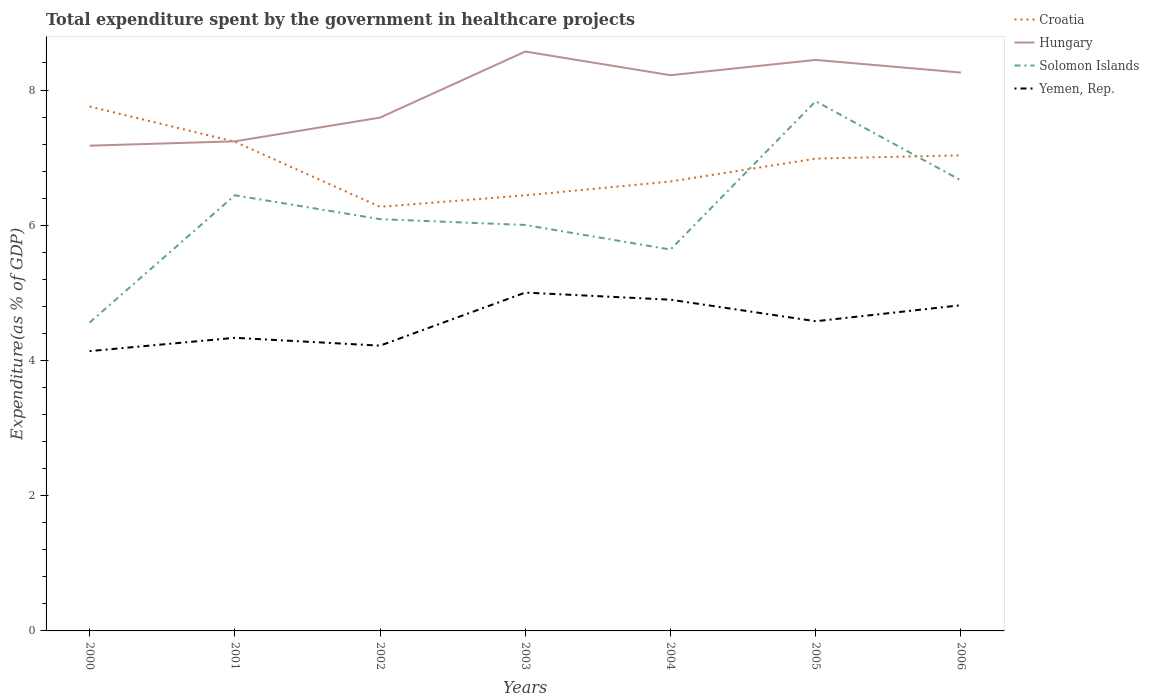Across all years, what is the maximum total expenditure spent by the government in healthcare projects in Hungary?
Your answer should be very brief. 7.18. In which year was the total expenditure spent by the government in healthcare projects in Croatia maximum?
Provide a succinct answer. 2002. What is the total total expenditure spent by the government in healthcare projects in Hungary in the graph?
Offer a terse response. -0.35. What is the difference between the highest and the second highest total expenditure spent by the government in healthcare projects in Solomon Islands?
Offer a very short reply. 3.27. What is the difference between the highest and the lowest total expenditure spent by the government in healthcare projects in Hungary?
Your answer should be very brief. 4. How many lines are there?
Ensure brevity in your answer.  4. What is the difference between two consecutive major ticks on the Y-axis?
Your response must be concise. 2. Are the values on the major ticks of Y-axis written in scientific E-notation?
Provide a short and direct response. No. Does the graph contain grids?
Offer a very short reply. No. How many legend labels are there?
Give a very brief answer. 4. How are the legend labels stacked?
Provide a succinct answer. Vertical. What is the title of the graph?
Ensure brevity in your answer.  Total expenditure spent by the government in healthcare projects. Does "Fiji" appear as one of the legend labels in the graph?
Provide a short and direct response. No. What is the label or title of the Y-axis?
Make the answer very short. Expenditure(as % of GDP). What is the Expenditure(as % of GDP) in Croatia in 2000?
Keep it short and to the point. 7.76. What is the Expenditure(as % of GDP) of Hungary in 2000?
Provide a short and direct response. 7.18. What is the Expenditure(as % of GDP) of Solomon Islands in 2000?
Make the answer very short. 4.56. What is the Expenditure(as % of GDP) of Yemen, Rep. in 2000?
Give a very brief answer. 4.14. What is the Expenditure(as % of GDP) in Croatia in 2001?
Make the answer very short. 7.24. What is the Expenditure(as % of GDP) in Hungary in 2001?
Keep it short and to the point. 7.24. What is the Expenditure(as % of GDP) of Solomon Islands in 2001?
Your answer should be compact. 6.44. What is the Expenditure(as % of GDP) in Yemen, Rep. in 2001?
Make the answer very short. 4.34. What is the Expenditure(as % of GDP) of Croatia in 2002?
Keep it short and to the point. 6.27. What is the Expenditure(as % of GDP) of Hungary in 2002?
Your answer should be compact. 7.59. What is the Expenditure(as % of GDP) in Solomon Islands in 2002?
Provide a succinct answer. 6.09. What is the Expenditure(as % of GDP) of Yemen, Rep. in 2002?
Keep it short and to the point. 4.22. What is the Expenditure(as % of GDP) of Croatia in 2003?
Ensure brevity in your answer.  6.44. What is the Expenditure(as % of GDP) in Hungary in 2003?
Your answer should be compact. 8.57. What is the Expenditure(as % of GDP) of Solomon Islands in 2003?
Offer a terse response. 6. What is the Expenditure(as % of GDP) of Yemen, Rep. in 2003?
Provide a short and direct response. 5. What is the Expenditure(as % of GDP) in Croatia in 2004?
Give a very brief answer. 6.65. What is the Expenditure(as % of GDP) of Hungary in 2004?
Keep it short and to the point. 8.22. What is the Expenditure(as % of GDP) of Solomon Islands in 2004?
Your answer should be compact. 5.64. What is the Expenditure(as % of GDP) in Yemen, Rep. in 2004?
Keep it short and to the point. 4.9. What is the Expenditure(as % of GDP) of Croatia in 2005?
Offer a terse response. 6.99. What is the Expenditure(as % of GDP) of Hungary in 2005?
Your response must be concise. 8.45. What is the Expenditure(as % of GDP) in Solomon Islands in 2005?
Your answer should be very brief. 7.83. What is the Expenditure(as % of GDP) in Yemen, Rep. in 2005?
Your response must be concise. 4.58. What is the Expenditure(as % of GDP) in Croatia in 2006?
Provide a succinct answer. 7.03. What is the Expenditure(as % of GDP) of Hungary in 2006?
Offer a terse response. 8.26. What is the Expenditure(as % of GDP) in Solomon Islands in 2006?
Provide a short and direct response. 6.66. What is the Expenditure(as % of GDP) in Yemen, Rep. in 2006?
Keep it short and to the point. 4.82. Across all years, what is the maximum Expenditure(as % of GDP) in Croatia?
Ensure brevity in your answer.  7.76. Across all years, what is the maximum Expenditure(as % of GDP) of Hungary?
Make the answer very short. 8.57. Across all years, what is the maximum Expenditure(as % of GDP) of Solomon Islands?
Your answer should be compact. 7.83. Across all years, what is the maximum Expenditure(as % of GDP) of Yemen, Rep.?
Provide a short and direct response. 5. Across all years, what is the minimum Expenditure(as % of GDP) of Croatia?
Your answer should be very brief. 6.27. Across all years, what is the minimum Expenditure(as % of GDP) of Hungary?
Provide a short and direct response. 7.18. Across all years, what is the minimum Expenditure(as % of GDP) in Solomon Islands?
Offer a terse response. 4.56. Across all years, what is the minimum Expenditure(as % of GDP) of Yemen, Rep.?
Offer a very short reply. 4.14. What is the total Expenditure(as % of GDP) in Croatia in the graph?
Offer a very short reply. 48.37. What is the total Expenditure(as % of GDP) in Hungary in the graph?
Your answer should be very brief. 55.5. What is the total Expenditure(as % of GDP) of Solomon Islands in the graph?
Provide a short and direct response. 43.24. What is the total Expenditure(as % of GDP) in Yemen, Rep. in the graph?
Provide a succinct answer. 31.99. What is the difference between the Expenditure(as % of GDP) of Croatia in 2000 and that in 2001?
Your answer should be compact. 0.52. What is the difference between the Expenditure(as % of GDP) in Hungary in 2000 and that in 2001?
Provide a short and direct response. -0.06. What is the difference between the Expenditure(as % of GDP) in Solomon Islands in 2000 and that in 2001?
Keep it short and to the point. -1.88. What is the difference between the Expenditure(as % of GDP) in Yemen, Rep. in 2000 and that in 2001?
Give a very brief answer. -0.2. What is the difference between the Expenditure(as % of GDP) of Croatia in 2000 and that in 2002?
Offer a very short reply. 1.48. What is the difference between the Expenditure(as % of GDP) of Hungary in 2000 and that in 2002?
Offer a very short reply. -0.42. What is the difference between the Expenditure(as % of GDP) of Solomon Islands in 2000 and that in 2002?
Provide a short and direct response. -1.53. What is the difference between the Expenditure(as % of GDP) of Yemen, Rep. in 2000 and that in 2002?
Your answer should be compact. -0.08. What is the difference between the Expenditure(as % of GDP) of Croatia in 2000 and that in 2003?
Provide a short and direct response. 1.31. What is the difference between the Expenditure(as % of GDP) of Hungary in 2000 and that in 2003?
Offer a terse response. -1.39. What is the difference between the Expenditure(as % of GDP) in Solomon Islands in 2000 and that in 2003?
Give a very brief answer. -1.44. What is the difference between the Expenditure(as % of GDP) of Yemen, Rep. in 2000 and that in 2003?
Offer a terse response. -0.87. What is the difference between the Expenditure(as % of GDP) of Croatia in 2000 and that in 2004?
Give a very brief answer. 1.11. What is the difference between the Expenditure(as % of GDP) in Hungary in 2000 and that in 2004?
Offer a terse response. -1.04. What is the difference between the Expenditure(as % of GDP) of Solomon Islands in 2000 and that in 2004?
Your answer should be very brief. -1.08. What is the difference between the Expenditure(as % of GDP) of Yemen, Rep. in 2000 and that in 2004?
Your response must be concise. -0.76. What is the difference between the Expenditure(as % of GDP) in Croatia in 2000 and that in 2005?
Make the answer very short. 0.77. What is the difference between the Expenditure(as % of GDP) of Hungary in 2000 and that in 2005?
Your response must be concise. -1.27. What is the difference between the Expenditure(as % of GDP) of Solomon Islands in 2000 and that in 2005?
Provide a succinct answer. -3.27. What is the difference between the Expenditure(as % of GDP) in Yemen, Rep. in 2000 and that in 2005?
Your response must be concise. -0.44. What is the difference between the Expenditure(as % of GDP) of Croatia in 2000 and that in 2006?
Keep it short and to the point. 0.72. What is the difference between the Expenditure(as % of GDP) in Hungary in 2000 and that in 2006?
Your answer should be very brief. -1.08. What is the difference between the Expenditure(as % of GDP) of Solomon Islands in 2000 and that in 2006?
Ensure brevity in your answer.  -2.1. What is the difference between the Expenditure(as % of GDP) in Yemen, Rep. in 2000 and that in 2006?
Your answer should be compact. -0.68. What is the difference between the Expenditure(as % of GDP) in Croatia in 2001 and that in 2002?
Your response must be concise. 0.96. What is the difference between the Expenditure(as % of GDP) of Hungary in 2001 and that in 2002?
Your answer should be compact. -0.35. What is the difference between the Expenditure(as % of GDP) of Solomon Islands in 2001 and that in 2002?
Ensure brevity in your answer.  0.35. What is the difference between the Expenditure(as % of GDP) in Yemen, Rep. in 2001 and that in 2002?
Ensure brevity in your answer.  0.12. What is the difference between the Expenditure(as % of GDP) of Croatia in 2001 and that in 2003?
Ensure brevity in your answer.  0.79. What is the difference between the Expenditure(as % of GDP) in Hungary in 2001 and that in 2003?
Keep it short and to the point. -1.33. What is the difference between the Expenditure(as % of GDP) in Solomon Islands in 2001 and that in 2003?
Make the answer very short. 0.44. What is the difference between the Expenditure(as % of GDP) of Yemen, Rep. in 2001 and that in 2003?
Offer a very short reply. -0.67. What is the difference between the Expenditure(as % of GDP) in Croatia in 2001 and that in 2004?
Ensure brevity in your answer.  0.59. What is the difference between the Expenditure(as % of GDP) of Hungary in 2001 and that in 2004?
Offer a very short reply. -0.98. What is the difference between the Expenditure(as % of GDP) in Solomon Islands in 2001 and that in 2004?
Your answer should be compact. 0.8. What is the difference between the Expenditure(as % of GDP) in Yemen, Rep. in 2001 and that in 2004?
Your response must be concise. -0.56. What is the difference between the Expenditure(as % of GDP) of Croatia in 2001 and that in 2005?
Make the answer very short. 0.25. What is the difference between the Expenditure(as % of GDP) of Hungary in 2001 and that in 2005?
Offer a terse response. -1.2. What is the difference between the Expenditure(as % of GDP) in Solomon Islands in 2001 and that in 2005?
Offer a very short reply. -1.39. What is the difference between the Expenditure(as % of GDP) of Yemen, Rep. in 2001 and that in 2005?
Offer a terse response. -0.25. What is the difference between the Expenditure(as % of GDP) of Croatia in 2001 and that in 2006?
Ensure brevity in your answer.  0.2. What is the difference between the Expenditure(as % of GDP) of Hungary in 2001 and that in 2006?
Your answer should be compact. -1.02. What is the difference between the Expenditure(as % of GDP) of Solomon Islands in 2001 and that in 2006?
Provide a short and direct response. -0.22. What is the difference between the Expenditure(as % of GDP) in Yemen, Rep. in 2001 and that in 2006?
Offer a very short reply. -0.48. What is the difference between the Expenditure(as % of GDP) in Croatia in 2002 and that in 2003?
Provide a short and direct response. -0.17. What is the difference between the Expenditure(as % of GDP) of Hungary in 2002 and that in 2003?
Your answer should be very brief. -0.98. What is the difference between the Expenditure(as % of GDP) in Solomon Islands in 2002 and that in 2003?
Your response must be concise. 0.09. What is the difference between the Expenditure(as % of GDP) in Yemen, Rep. in 2002 and that in 2003?
Keep it short and to the point. -0.78. What is the difference between the Expenditure(as % of GDP) of Croatia in 2002 and that in 2004?
Provide a succinct answer. -0.37. What is the difference between the Expenditure(as % of GDP) in Hungary in 2002 and that in 2004?
Make the answer very short. -0.63. What is the difference between the Expenditure(as % of GDP) of Solomon Islands in 2002 and that in 2004?
Give a very brief answer. 0.45. What is the difference between the Expenditure(as % of GDP) in Yemen, Rep. in 2002 and that in 2004?
Keep it short and to the point. -0.68. What is the difference between the Expenditure(as % of GDP) of Croatia in 2002 and that in 2005?
Your answer should be very brief. -0.71. What is the difference between the Expenditure(as % of GDP) of Hungary in 2002 and that in 2005?
Ensure brevity in your answer.  -0.85. What is the difference between the Expenditure(as % of GDP) in Solomon Islands in 2002 and that in 2005?
Make the answer very short. -1.74. What is the difference between the Expenditure(as % of GDP) in Yemen, Rep. in 2002 and that in 2005?
Your answer should be compact. -0.36. What is the difference between the Expenditure(as % of GDP) in Croatia in 2002 and that in 2006?
Make the answer very short. -0.76. What is the difference between the Expenditure(as % of GDP) in Hungary in 2002 and that in 2006?
Your response must be concise. -0.67. What is the difference between the Expenditure(as % of GDP) in Solomon Islands in 2002 and that in 2006?
Provide a succinct answer. -0.57. What is the difference between the Expenditure(as % of GDP) of Yemen, Rep. in 2002 and that in 2006?
Ensure brevity in your answer.  -0.6. What is the difference between the Expenditure(as % of GDP) in Croatia in 2003 and that in 2004?
Give a very brief answer. -0.2. What is the difference between the Expenditure(as % of GDP) in Hungary in 2003 and that in 2004?
Your answer should be very brief. 0.35. What is the difference between the Expenditure(as % of GDP) of Solomon Islands in 2003 and that in 2004?
Provide a short and direct response. 0.36. What is the difference between the Expenditure(as % of GDP) of Yemen, Rep. in 2003 and that in 2004?
Give a very brief answer. 0.11. What is the difference between the Expenditure(as % of GDP) in Croatia in 2003 and that in 2005?
Make the answer very short. -0.54. What is the difference between the Expenditure(as % of GDP) of Hungary in 2003 and that in 2005?
Keep it short and to the point. 0.12. What is the difference between the Expenditure(as % of GDP) in Solomon Islands in 2003 and that in 2005?
Offer a terse response. -1.83. What is the difference between the Expenditure(as % of GDP) of Yemen, Rep. in 2003 and that in 2005?
Your answer should be compact. 0.42. What is the difference between the Expenditure(as % of GDP) in Croatia in 2003 and that in 2006?
Offer a very short reply. -0.59. What is the difference between the Expenditure(as % of GDP) of Hungary in 2003 and that in 2006?
Provide a short and direct response. 0.31. What is the difference between the Expenditure(as % of GDP) of Solomon Islands in 2003 and that in 2006?
Provide a succinct answer. -0.66. What is the difference between the Expenditure(as % of GDP) in Yemen, Rep. in 2003 and that in 2006?
Your response must be concise. 0.19. What is the difference between the Expenditure(as % of GDP) of Croatia in 2004 and that in 2005?
Make the answer very short. -0.34. What is the difference between the Expenditure(as % of GDP) of Hungary in 2004 and that in 2005?
Offer a very short reply. -0.23. What is the difference between the Expenditure(as % of GDP) in Solomon Islands in 2004 and that in 2005?
Your answer should be compact. -2.19. What is the difference between the Expenditure(as % of GDP) in Yemen, Rep. in 2004 and that in 2005?
Your answer should be very brief. 0.32. What is the difference between the Expenditure(as % of GDP) in Croatia in 2004 and that in 2006?
Offer a very short reply. -0.39. What is the difference between the Expenditure(as % of GDP) in Hungary in 2004 and that in 2006?
Your answer should be compact. -0.04. What is the difference between the Expenditure(as % of GDP) of Solomon Islands in 2004 and that in 2006?
Make the answer very short. -1.02. What is the difference between the Expenditure(as % of GDP) in Yemen, Rep. in 2004 and that in 2006?
Provide a succinct answer. 0.08. What is the difference between the Expenditure(as % of GDP) in Croatia in 2005 and that in 2006?
Your response must be concise. -0.05. What is the difference between the Expenditure(as % of GDP) in Hungary in 2005 and that in 2006?
Keep it short and to the point. 0.19. What is the difference between the Expenditure(as % of GDP) of Solomon Islands in 2005 and that in 2006?
Keep it short and to the point. 1.17. What is the difference between the Expenditure(as % of GDP) in Yemen, Rep. in 2005 and that in 2006?
Offer a terse response. -0.24. What is the difference between the Expenditure(as % of GDP) of Croatia in 2000 and the Expenditure(as % of GDP) of Hungary in 2001?
Provide a short and direct response. 0.51. What is the difference between the Expenditure(as % of GDP) of Croatia in 2000 and the Expenditure(as % of GDP) of Solomon Islands in 2001?
Provide a short and direct response. 1.31. What is the difference between the Expenditure(as % of GDP) in Croatia in 2000 and the Expenditure(as % of GDP) in Yemen, Rep. in 2001?
Offer a very short reply. 3.42. What is the difference between the Expenditure(as % of GDP) in Hungary in 2000 and the Expenditure(as % of GDP) in Solomon Islands in 2001?
Offer a terse response. 0.73. What is the difference between the Expenditure(as % of GDP) in Hungary in 2000 and the Expenditure(as % of GDP) in Yemen, Rep. in 2001?
Keep it short and to the point. 2.84. What is the difference between the Expenditure(as % of GDP) of Solomon Islands in 2000 and the Expenditure(as % of GDP) of Yemen, Rep. in 2001?
Keep it short and to the point. 0.23. What is the difference between the Expenditure(as % of GDP) in Croatia in 2000 and the Expenditure(as % of GDP) in Hungary in 2002?
Give a very brief answer. 0.16. What is the difference between the Expenditure(as % of GDP) of Croatia in 2000 and the Expenditure(as % of GDP) of Solomon Islands in 2002?
Offer a very short reply. 1.67. What is the difference between the Expenditure(as % of GDP) of Croatia in 2000 and the Expenditure(as % of GDP) of Yemen, Rep. in 2002?
Make the answer very short. 3.54. What is the difference between the Expenditure(as % of GDP) of Hungary in 2000 and the Expenditure(as % of GDP) of Solomon Islands in 2002?
Keep it short and to the point. 1.09. What is the difference between the Expenditure(as % of GDP) in Hungary in 2000 and the Expenditure(as % of GDP) in Yemen, Rep. in 2002?
Give a very brief answer. 2.96. What is the difference between the Expenditure(as % of GDP) in Solomon Islands in 2000 and the Expenditure(as % of GDP) in Yemen, Rep. in 2002?
Offer a very short reply. 0.34. What is the difference between the Expenditure(as % of GDP) in Croatia in 2000 and the Expenditure(as % of GDP) in Hungary in 2003?
Your answer should be compact. -0.81. What is the difference between the Expenditure(as % of GDP) in Croatia in 2000 and the Expenditure(as % of GDP) in Solomon Islands in 2003?
Give a very brief answer. 1.75. What is the difference between the Expenditure(as % of GDP) of Croatia in 2000 and the Expenditure(as % of GDP) of Yemen, Rep. in 2003?
Your answer should be compact. 2.75. What is the difference between the Expenditure(as % of GDP) in Hungary in 2000 and the Expenditure(as % of GDP) in Solomon Islands in 2003?
Provide a succinct answer. 1.17. What is the difference between the Expenditure(as % of GDP) in Hungary in 2000 and the Expenditure(as % of GDP) in Yemen, Rep. in 2003?
Offer a very short reply. 2.17. What is the difference between the Expenditure(as % of GDP) of Solomon Islands in 2000 and the Expenditure(as % of GDP) of Yemen, Rep. in 2003?
Your response must be concise. -0.44. What is the difference between the Expenditure(as % of GDP) in Croatia in 2000 and the Expenditure(as % of GDP) in Hungary in 2004?
Your answer should be compact. -0.46. What is the difference between the Expenditure(as % of GDP) of Croatia in 2000 and the Expenditure(as % of GDP) of Solomon Islands in 2004?
Your answer should be very brief. 2.12. What is the difference between the Expenditure(as % of GDP) of Croatia in 2000 and the Expenditure(as % of GDP) of Yemen, Rep. in 2004?
Your response must be concise. 2.86. What is the difference between the Expenditure(as % of GDP) in Hungary in 2000 and the Expenditure(as % of GDP) in Solomon Islands in 2004?
Give a very brief answer. 1.54. What is the difference between the Expenditure(as % of GDP) of Hungary in 2000 and the Expenditure(as % of GDP) of Yemen, Rep. in 2004?
Provide a succinct answer. 2.28. What is the difference between the Expenditure(as % of GDP) of Solomon Islands in 2000 and the Expenditure(as % of GDP) of Yemen, Rep. in 2004?
Ensure brevity in your answer.  -0.34. What is the difference between the Expenditure(as % of GDP) of Croatia in 2000 and the Expenditure(as % of GDP) of Hungary in 2005?
Offer a terse response. -0.69. What is the difference between the Expenditure(as % of GDP) of Croatia in 2000 and the Expenditure(as % of GDP) of Solomon Islands in 2005?
Provide a succinct answer. -0.08. What is the difference between the Expenditure(as % of GDP) of Croatia in 2000 and the Expenditure(as % of GDP) of Yemen, Rep. in 2005?
Make the answer very short. 3.18. What is the difference between the Expenditure(as % of GDP) of Hungary in 2000 and the Expenditure(as % of GDP) of Solomon Islands in 2005?
Your answer should be compact. -0.66. What is the difference between the Expenditure(as % of GDP) in Hungary in 2000 and the Expenditure(as % of GDP) in Yemen, Rep. in 2005?
Ensure brevity in your answer.  2.6. What is the difference between the Expenditure(as % of GDP) in Solomon Islands in 2000 and the Expenditure(as % of GDP) in Yemen, Rep. in 2005?
Provide a short and direct response. -0.02. What is the difference between the Expenditure(as % of GDP) in Croatia in 2000 and the Expenditure(as % of GDP) in Hungary in 2006?
Provide a succinct answer. -0.5. What is the difference between the Expenditure(as % of GDP) in Croatia in 2000 and the Expenditure(as % of GDP) in Solomon Islands in 2006?
Your answer should be compact. 1.09. What is the difference between the Expenditure(as % of GDP) in Croatia in 2000 and the Expenditure(as % of GDP) in Yemen, Rep. in 2006?
Offer a terse response. 2.94. What is the difference between the Expenditure(as % of GDP) in Hungary in 2000 and the Expenditure(as % of GDP) in Solomon Islands in 2006?
Provide a short and direct response. 0.51. What is the difference between the Expenditure(as % of GDP) in Hungary in 2000 and the Expenditure(as % of GDP) in Yemen, Rep. in 2006?
Make the answer very short. 2.36. What is the difference between the Expenditure(as % of GDP) of Solomon Islands in 2000 and the Expenditure(as % of GDP) of Yemen, Rep. in 2006?
Offer a very short reply. -0.26. What is the difference between the Expenditure(as % of GDP) of Croatia in 2001 and the Expenditure(as % of GDP) of Hungary in 2002?
Your answer should be very brief. -0.36. What is the difference between the Expenditure(as % of GDP) in Croatia in 2001 and the Expenditure(as % of GDP) in Solomon Islands in 2002?
Offer a very short reply. 1.15. What is the difference between the Expenditure(as % of GDP) of Croatia in 2001 and the Expenditure(as % of GDP) of Yemen, Rep. in 2002?
Your response must be concise. 3.02. What is the difference between the Expenditure(as % of GDP) in Hungary in 2001 and the Expenditure(as % of GDP) in Solomon Islands in 2002?
Make the answer very short. 1.15. What is the difference between the Expenditure(as % of GDP) of Hungary in 2001 and the Expenditure(as % of GDP) of Yemen, Rep. in 2002?
Offer a terse response. 3.02. What is the difference between the Expenditure(as % of GDP) in Solomon Islands in 2001 and the Expenditure(as % of GDP) in Yemen, Rep. in 2002?
Give a very brief answer. 2.22. What is the difference between the Expenditure(as % of GDP) in Croatia in 2001 and the Expenditure(as % of GDP) in Hungary in 2003?
Offer a very short reply. -1.33. What is the difference between the Expenditure(as % of GDP) of Croatia in 2001 and the Expenditure(as % of GDP) of Solomon Islands in 2003?
Your answer should be very brief. 1.23. What is the difference between the Expenditure(as % of GDP) in Croatia in 2001 and the Expenditure(as % of GDP) in Yemen, Rep. in 2003?
Keep it short and to the point. 2.23. What is the difference between the Expenditure(as % of GDP) in Hungary in 2001 and the Expenditure(as % of GDP) in Solomon Islands in 2003?
Make the answer very short. 1.24. What is the difference between the Expenditure(as % of GDP) of Hungary in 2001 and the Expenditure(as % of GDP) of Yemen, Rep. in 2003?
Provide a succinct answer. 2.24. What is the difference between the Expenditure(as % of GDP) of Solomon Islands in 2001 and the Expenditure(as % of GDP) of Yemen, Rep. in 2003?
Your answer should be compact. 1.44. What is the difference between the Expenditure(as % of GDP) of Croatia in 2001 and the Expenditure(as % of GDP) of Hungary in 2004?
Offer a very short reply. -0.98. What is the difference between the Expenditure(as % of GDP) of Croatia in 2001 and the Expenditure(as % of GDP) of Solomon Islands in 2004?
Provide a succinct answer. 1.6. What is the difference between the Expenditure(as % of GDP) of Croatia in 2001 and the Expenditure(as % of GDP) of Yemen, Rep. in 2004?
Offer a terse response. 2.34. What is the difference between the Expenditure(as % of GDP) in Hungary in 2001 and the Expenditure(as % of GDP) in Solomon Islands in 2004?
Your answer should be compact. 1.6. What is the difference between the Expenditure(as % of GDP) in Hungary in 2001 and the Expenditure(as % of GDP) in Yemen, Rep. in 2004?
Give a very brief answer. 2.34. What is the difference between the Expenditure(as % of GDP) in Solomon Islands in 2001 and the Expenditure(as % of GDP) in Yemen, Rep. in 2004?
Provide a short and direct response. 1.54. What is the difference between the Expenditure(as % of GDP) of Croatia in 2001 and the Expenditure(as % of GDP) of Hungary in 2005?
Provide a succinct answer. -1.21. What is the difference between the Expenditure(as % of GDP) in Croatia in 2001 and the Expenditure(as % of GDP) in Solomon Islands in 2005?
Give a very brief answer. -0.6. What is the difference between the Expenditure(as % of GDP) of Croatia in 2001 and the Expenditure(as % of GDP) of Yemen, Rep. in 2005?
Ensure brevity in your answer.  2.66. What is the difference between the Expenditure(as % of GDP) in Hungary in 2001 and the Expenditure(as % of GDP) in Solomon Islands in 2005?
Give a very brief answer. -0.59. What is the difference between the Expenditure(as % of GDP) in Hungary in 2001 and the Expenditure(as % of GDP) in Yemen, Rep. in 2005?
Make the answer very short. 2.66. What is the difference between the Expenditure(as % of GDP) in Solomon Islands in 2001 and the Expenditure(as % of GDP) in Yemen, Rep. in 2005?
Give a very brief answer. 1.86. What is the difference between the Expenditure(as % of GDP) of Croatia in 2001 and the Expenditure(as % of GDP) of Hungary in 2006?
Keep it short and to the point. -1.02. What is the difference between the Expenditure(as % of GDP) in Croatia in 2001 and the Expenditure(as % of GDP) in Solomon Islands in 2006?
Keep it short and to the point. 0.57. What is the difference between the Expenditure(as % of GDP) in Croatia in 2001 and the Expenditure(as % of GDP) in Yemen, Rep. in 2006?
Offer a terse response. 2.42. What is the difference between the Expenditure(as % of GDP) of Hungary in 2001 and the Expenditure(as % of GDP) of Solomon Islands in 2006?
Your response must be concise. 0.58. What is the difference between the Expenditure(as % of GDP) in Hungary in 2001 and the Expenditure(as % of GDP) in Yemen, Rep. in 2006?
Give a very brief answer. 2.42. What is the difference between the Expenditure(as % of GDP) of Solomon Islands in 2001 and the Expenditure(as % of GDP) of Yemen, Rep. in 2006?
Your answer should be compact. 1.63. What is the difference between the Expenditure(as % of GDP) in Croatia in 2002 and the Expenditure(as % of GDP) in Hungary in 2003?
Give a very brief answer. -2.3. What is the difference between the Expenditure(as % of GDP) of Croatia in 2002 and the Expenditure(as % of GDP) of Solomon Islands in 2003?
Make the answer very short. 0.27. What is the difference between the Expenditure(as % of GDP) in Croatia in 2002 and the Expenditure(as % of GDP) in Yemen, Rep. in 2003?
Ensure brevity in your answer.  1.27. What is the difference between the Expenditure(as % of GDP) of Hungary in 2002 and the Expenditure(as % of GDP) of Solomon Islands in 2003?
Provide a succinct answer. 1.59. What is the difference between the Expenditure(as % of GDP) of Hungary in 2002 and the Expenditure(as % of GDP) of Yemen, Rep. in 2003?
Make the answer very short. 2.59. What is the difference between the Expenditure(as % of GDP) in Solomon Islands in 2002 and the Expenditure(as % of GDP) in Yemen, Rep. in 2003?
Offer a terse response. 1.09. What is the difference between the Expenditure(as % of GDP) of Croatia in 2002 and the Expenditure(as % of GDP) of Hungary in 2004?
Give a very brief answer. -1.95. What is the difference between the Expenditure(as % of GDP) in Croatia in 2002 and the Expenditure(as % of GDP) in Solomon Islands in 2004?
Ensure brevity in your answer.  0.63. What is the difference between the Expenditure(as % of GDP) of Croatia in 2002 and the Expenditure(as % of GDP) of Yemen, Rep. in 2004?
Make the answer very short. 1.37. What is the difference between the Expenditure(as % of GDP) of Hungary in 2002 and the Expenditure(as % of GDP) of Solomon Islands in 2004?
Provide a succinct answer. 1.95. What is the difference between the Expenditure(as % of GDP) of Hungary in 2002 and the Expenditure(as % of GDP) of Yemen, Rep. in 2004?
Your response must be concise. 2.69. What is the difference between the Expenditure(as % of GDP) of Solomon Islands in 2002 and the Expenditure(as % of GDP) of Yemen, Rep. in 2004?
Make the answer very short. 1.19. What is the difference between the Expenditure(as % of GDP) of Croatia in 2002 and the Expenditure(as % of GDP) of Hungary in 2005?
Make the answer very short. -2.17. What is the difference between the Expenditure(as % of GDP) of Croatia in 2002 and the Expenditure(as % of GDP) of Solomon Islands in 2005?
Give a very brief answer. -1.56. What is the difference between the Expenditure(as % of GDP) of Croatia in 2002 and the Expenditure(as % of GDP) of Yemen, Rep. in 2005?
Give a very brief answer. 1.69. What is the difference between the Expenditure(as % of GDP) in Hungary in 2002 and the Expenditure(as % of GDP) in Solomon Islands in 2005?
Your response must be concise. -0.24. What is the difference between the Expenditure(as % of GDP) of Hungary in 2002 and the Expenditure(as % of GDP) of Yemen, Rep. in 2005?
Your answer should be compact. 3.01. What is the difference between the Expenditure(as % of GDP) in Solomon Islands in 2002 and the Expenditure(as % of GDP) in Yemen, Rep. in 2005?
Your response must be concise. 1.51. What is the difference between the Expenditure(as % of GDP) of Croatia in 2002 and the Expenditure(as % of GDP) of Hungary in 2006?
Your answer should be compact. -1.99. What is the difference between the Expenditure(as % of GDP) of Croatia in 2002 and the Expenditure(as % of GDP) of Solomon Islands in 2006?
Offer a terse response. -0.39. What is the difference between the Expenditure(as % of GDP) of Croatia in 2002 and the Expenditure(as % of GDP) of Yemen, Rep. in 2006?
Offer a terse response. 1.46. What is the difference between the Expenditure(as % of GDP) in Hungary in 2002 and the Expenditure(as % of GDP) in Solomon Islands in 2006?
Your response must be concise. 0.93. What is the difference between the Expenditure(as % of GDP) in Hungary in 2002 and the Expenditure(as % of GDP) in Yemen, Rep. in 2006?
Keep it short and to the point. 2.78. What is the difference between the Expenditure(as % of GDP) in Solomon Islands in 2002 and the Expenditure(as % of GDP) in Yemen, Rep. in 2006?
Your answer should be compact. 1.27. What is the difference between the Expenditure(as % of GDP) of Croatia in 2003 and the Expenditure(as % of GDP) of Hungary in 2004?
Offer a very short reply. -1.78. What is the difference between the Expenditure(as % of GDP) of Croatia in 2003 and the Expenditure(as % of GDP) of Solomon Islands in 2004?
Your response must be concise. 0.8. What is the difference between the Expenditure(as % of GDP) of Croatia in 2003 and the Expenditure(as % of GDP) of Yemen, Rep. in 2004?
Provide a short and direct response. 1.54. What is the difference between the Expenditure(as % of GDP) in Hungary in 2003 and the Expenditure(as % of GDP) in Solomon Islands in 2004?
Ensure brevity in your answer.  2.93. What is the difference between the Expenditure(as % of GDP) in Hungary in 2003 and the Expenditure(as % of GDP) in Yemen, Rep. in 2004?
Ensure brevity in your answer.  3.67. What is the difference between the Expenditure(as % of GDP) of Solomon Islands in 2003 and the Expenditure(as % of GDP) of Yemen, Rep. in 2004?
Your answer should be compact. 1.11. What is the difference between the Expenditure(as % of GDP) in Croatia in 2003 and the Expenditure(as % of GDP) in Hungary in 2005?
Provide a succinct answer. -2. What is the difference between the Expenditure(as % of GDP) in Croatia in 2003 and the Expenditure(as % of GDP) in Solomon Islands in 2005?
Your answer should be compact. -1.39. What is the difference between the Expenditure(as % of GDP) of Croatia in 2003 and the Expenditure(as % of GDP) of Yemen, Rep. in 2005?
Offer a very short reply. 1.86. What is the difference between the Expenditure(as % of GDP) of Hungary in 2003 and the Expenditure(as % of GDP) of Solomon Islands in 2005?
Keep it short and to the point. 0.73. What is the difference between the Expenditure(as % of GDP) of Hungary in 2003 and the Expenditure(as % of GDP) of Yemen, Rep. in 2005?
Your answer should be compact. 3.99. What is the difference between the Expenditure(as % of GDP) in Solomon Islands in 2003 and the Expenditure(as % of GDP) in Yemen, Rep. in 2005?
Ensure brevity in your answer.  1.42. What is the difference between the Expenditure(as % of GDP) of Croatia in 2003 and the Expenditure(as % of GDP) of Hungary in 2006?
Provide a short and direct response. -1.82. What is the difference between the Expenditure(as % of GDP) of Croatia in 2003 and the Expenditure(as % of GDP) of Solomon Islands in 2006?
Offer a terse response. -0.22. What is the difference between the Expenditure(as % of GDP) in Croatia in 2003 and the Expenditure(as % of GDP) in Yemen, Rep. in 2006?
Ensure brevity in your answer.  1.63. What is the difference between the Expenditure(as % of GDP) in Hungary in 2003 and the Expenditure(as % of GDP) in Solomon Islands in 2006?
Offer a very short reply. 1.91. What is the difference between the Expenditure(as % of GDP) in Hungary in 2003 and the Expenditure(as % of GDP) in Yemen, Rep. in 2006?
Provide a short and direct response. 3.75. What is the difference between the Expenditure(as % of GDP) of Solomon Islands in 2003 and the Expenditure(as % of GDP) of Yemen, Rep. in 2006?
Make the answer very short. 1.19. What is the difference between the Expenditure(as % of GDP) in Croatia in 2004 and the Expenditure(as % of GDP) in Hungary in 2005?
Ensure brevity in your answer.  -1.8. What is the difference between the Expenditure(as % of GDP) in Croatia in 2004 and the Expenditure(as % of GDP) in Solomon Islands in 2005?
Offer a terse response. -1.19. What is the difference between the Expenditure(as % of GDP) in Croatia in 2004 and the Expenditure(as % of GDP) in Yemen, Rep. in 2005?
Offer a terse response. 2.07. What is the difference between the Expenditure(as % of GDP) in Hungary in 2004 and the Expenditure(as % of GDP) in Solomon Islands in 2005?
Keep it short and to the point. 0.38. What is the difference between the Expenditure(as % of GDP) of Hungary in 2004 and the Expenditure(as % of GDP) of Yemen, Rep. in 2005?
Offer a very short reply. 3.64. What is the difference between the Expenditure(as % of GDP) of Solomon Islands in 2004 and the Expenditure(as % of GDP) of Yemen, Rep. in 2005?
Give a very brief answer. 1.06. What is the difference between the Expenditure(as % of GDP) of Croatia in 2004 and the Expenditure(as % of GDP) of Hungary in 2006?
Make the answer very short. -1.61. What is the difference between the Expenditure(as % of GDP) of Croatia in 2004 and the Expenditure(as % of GDP) of Solomon Islands in 2006?
Provide a short and direct response. -0.02. What is the difference between the Expenditure(as % of GDP) of Croatia in 2004 and the Expenditure(as % of GDP) of Yemen, Rep. in 2006?
Your response must be concise. 1.83. What is the difference between the Expenditure(as % of GDP) in Hungary in 2004 and the Expenditure(as % of GDP) in Solomon Islands in 2006?
Provide a short and direct response. 1.56. What is the difference between the Expenditure(as % of GDP) of Hungary in 2004 and the Expenditure(as % of GDP) of Yemen, Rep. in 2006?
Make the answer very short. 3.4. What is the difference between the Expenditure(as % of GDP) of Solomon Islands in 2004 and the Expenditure(as % of GDP) of Yemen, Rep. in 2006?
Give a very brief answer. 0.82. What is the difference between the Expenditure(as % of GDP) in Croatia in 2005 and the Expenditure(as % of GDP) in Hungary in 2006?
Your answer should be compact. -1.27. What is the difference between the Expenditure(as % of GDP) of Croatia in 2005 and the Expenditure(as % of GDP) of Solomon Islands in 2006?
Offer a terse response. 0.32. What is the difference between the Expenditure(as % of GDP) in Croatia in 2005 and the Expenditure(as % of GDP) in Yemen, Rep. in 2006?
Your answer should be compact. 2.17. What is the difference between the Expenditure(as % of GDP) in Hungary in 2005 and the Expenditure(as % of GDP) in Solomon Islands in 2006?
Your answer should be very brief. 1.78. What is the difference between the Expenditure(as % of GDP) of Hungary in 2005 and the Expenditure(as % of GDP) of Yemen, Rep. in 2006?
Provide a succinct answer. 3.63. What is the difference between the Expenditure(as % of GDP) in Solomon Islands in 2005 and the Expenditure(as % of GDP) in Yemen, Rep. in 2006?
Your answer should be compact. 3.02. What is the average Expenditure(as % of GDP) in Croatia per year?
Provide a succinct answer. 6.91. What is the average Expenditure(as % of GDP) of Hungary per year?
Your answer should be compact. 7.93. What is the average Expenditure(as % of GDP) in Solomon Islands per year?
Your answer should be compact. 6.18. What is the average Expenditure(as % of GDP) in Yemen, Rep. per year?
Offer a very short reply. 4.57. In the year 2000, what is the difference between the Expenditure(as % of GDP) of Croatia and Expenditure(as % of GDP) of Hungary?
Give a very brief answer. 0.58. In the year 2000, what is the difference between the Expenditure(as % of GDP) in Croatia and Expenditure(as % of GDP) in Solomon Islands?
Offer a terse response. 3.2. In the year 2000, what is the difference between the Expenditure(as % of GDP) in Croatia and Expenditure(as % of GDP) in Yemen, Rep.?
Keep it short and to the point. 3.62. In the year 2000, what is the difference between the Expenditure(as % of GDP) of Hungary and Expenditure(as % of GDP) of Solomon Islands?
Provide a succinct answer. 2.62. In the year 2000, what is the difference between the Expenditure(as % of GDP) of Hungary and Expenditure(as % of GDP) of Yemen, Rep.?
Make the answer very short. 3.04. In the year 2000, what is the difference between the Expenditure(as % of GDP) in Solomon Islands and Expenditure(as % of GDP) in Yemen, Rep.?
Your answer should be compact. 0.42. In the year 2001, what is the difference between the Expenditure(as % of GDP) of Croatia and Expenditure(as % of GDP) of Hungary?
Offer a terse response. -0.01. In the year 2001, what is the difference between the Expenditure(as % of GDP) of Croatia and Expenditure(as % of GDP) of Solomon Islands?
Provide a short and direct response. 0.79. In the year 2001, what is the difference between the Expenditure(as % of GDP) in Croatia and Expenditure(as % of GDP) in Yemen, Rep.?
Provide a short and direct response. 2.9. In the year 2001, what is the difference between the Expenditure(as % of GDP) of Hungary and Expenditure(as % of GDP) of Solomon Islands?
Your response must be concise. 0.8. In the year 2001, what is the difference between the Expenditure(as % of GDP) in Hungary and Expenditure(as % of GDP) in Yemen, Rep.?
Keep it short and to the point. 2.91. In the year 2001, what is the difference between the Expenditure(as % of GDP) in Solomon Islands and Expenditure(as % of GDP) in Yemen, Rep.?
Your response must be concise. 2.11. In the year 2002, what is the difference between the Expenditure(as % of GDP) in Croatia and Expenditure(as % of GDP) in Hungary?
Give a very brief answer. -1.32. In the year 2002, what is the difference between the Expenditure(as % of GDP) in Croatia and Expenditure(as % of GDP) in Solomon Islands?
Provide a short and direct response. 0.18. In the year 2002, what is the difference between the Expenditure(as % of GDP) of Croatia and Expenditure(as % of GDP) of Yemen, Rep.?
Your response must be concise. 2.05. In the year 2002, what is the difference between the Expenditure(as % of GDP) in Hungary and Expenditure(as % of GDP) in Solomon Islands?
Offer a terse response. 1.5. In the year 2002, what is the difference between the Expenditure(as % of GDP) in Hungary and Expenditure(as % of GDP) in Yemen, Rep.?
Keep it short and to the point. 3.37. In the year 2002, what is the difference between the Expenditure(as % of GDP) in Solomon Islands and Expenditure(as % of GDP) in Yemen, Rep.?
Your answer should be compact. 1.87. In the year 2003, what is the difference between the Expenditure(as % of GDP) in Croatia and Expenditure(as % of GDP) in Hungary?
Your response must be concise. -2.13. In the year 2003, what is the difference between the Expenditure(as % of GDP) of Croatia and Expenditure(as % of GDP) of Solomon Islands?
Offer a very short reply. 0.44. In the year 2003, what is the difference between the Expenditure(as % of GDP) in Croatia and Expenditure(as % of GDP) in Yemen, Rep.?
Your answer should be very brief. 1.44. In the year 2003, what is the difference between the Expenditure(as % of GDP) in Hungary and Expenditure(as % of GDP) in Solomon Islands?
Provide a short and direct response. 2.57. In the year 2003, what is the difference between the Expenditure(as % of GDP) of Hungary and Expenditure(as % of GDP) of Yemen, Rep.?
Make the answer very short. 3.57. In the year 2003, what is the difference between the Expenditure(as % of GDP) in Solomon Islands and Expenditure(as % of GDP) in Yemen, Rep.?
Offer a very short reply. 1. In the year 2004, what is the difference between the Expenditure(as % of GDP) in Croatia and Expenditure(as % of GDP) in Hungary?
Give a very brief answer. -1.57. In the year 2004, what is the difference between the Expenditure(as % of GDP) of Croatia and Expenditure(as % of GDP) of Solomon Islands?
Provide a short and direct response. 1.01. In the year 2004, what is the difference between the Expenditure(as % of GDP) in Croatia and Expenditure(as % of GDP) in Yemen, Rep.?
Offer a terse response. 1.75. In the year 2004, what is the difference between the Expenditure(as % of GDP) in Hungary and Expenditure(as % of GDP) in Solomon Islands?
Your answer should be compact. 2.58. In the year 2004, what is the difference between the Expenditure(as % of GDP) of Hungary and Expenditure(as % of GDP) of Yemen, Rep.?
Your answer should be compact. 3.32. In the year 2004, what is the difference between the Expenditure(as % of GDP) of Solomon Islands and Expenditure(as % of GDP) of Yemen, Rep.?
Your response must be concise. 0.74. In the year 2005, what is the difference between the Expenditure(as % of GDP) of Croatia and Expenditure(as % of GDP) of Hungary?
Make the answer very short. -1.46. In the year 2005, what is the difference between the Expenditure(as % of GDP) of Croatia and Expenditure(as % of GDP) of Solomon Islands?
Give a very brief answer. -0.85. In the year 2005, what is the difference between the Expenditure(as % of GDP) of Croatia and Expenditure(as % of GDP) of Yemen, Rep.?
Provide a succinct answer. 2.41. In the year 2005, what is the difference between the Expenditure(as % of GDP) of Hungary and Expenditure(as % of GDP) of Solomon Islands?
Provide a short and direct response. 0.61. In the year 2005, what is the difference between the Expenditure(as % of GDP) in Hungary and Expenditure(as % of GDP) in Yemen, Rep.?
Your response must be concise. 3.87. In the year 2005, what is the difference between the Expenditure(as % of GDP) in Solomon Islands and Expenditure(as % of GDP) in Yemen, Rep.?
Give a very brief answer. 3.25. In the year 2006, what is the difference between the Expenditure(as % of GDP) in Croatia and Expenditure(as % of GDP) in Hungary?
Keep it short and to the point. -1.22. In the year 2006, what is the difference between the Expenditure(as % of GDP) of Croatia and Expenditure(as % of GDP) of Solomon Islands?
Make the answer very short. 0.37. In the year 2006, what is the difference between the Expenditure(as % of GDP) of Croatia and Expenditure(as % of GDP) of Yemen, Rep.?
Make the answer very short. 2.22. In the year 2006, what is the difference between the Expenditure(as % of GDP) of Hungary and Expenditure(as % of GDP) of Solomon Islands?
Offer a very short reply. 1.59. In the year 2006, what is the difference between the Expenditure(as % of GDP) in Hungary and Expenditure(as % of GDP) in Yemen, Rep.?
Offer a very short reply. 3.44. In the year 2006, what is the difference between the Expenditure(as % of GDP) in Solomon Islands and Expenditure(as % of GDP) in Yemen, Rep.?
Your answer should be compact. 1.85. What is the ratio of the Expenditure(as % of GDP) of Croatia in 2000 to that in 2001?
Make the answer very short. 1.07. What is the ratio of the Expenditure(as % of GDP) in Solomon Islands in 2000 to that in 2001?
Make the answer very short. 0.71. What is the ratio of the Expenditure(as % of GDP) of Yemen, Rep. in 2000 to that in 2001?
Make the answer very short. 0.95. What is the ratio of the Expenditure(as % of GDP) of Croatia in 2000 to that in 2002?
Make the answer very short. 1.24. What is the ratio of the Expenditure(as % of GDP) in Hungary in 2000 to that in 2002?
Ensure brevity in your answer.  0.95. What is the ratio of the Expenditure(as % of GDP) of Solomon Islands in 2000 to that in 2002?
Your answer should be compact. 0.75. What is the ratio of the Expenditure(as % of GDP) in Yemen, Rep. in 2000 to that in 2002?
Ensure brevity in your answer.  0.98. What is the ratio of the Expenditure(as % of GDP) of Croatia in 2000 to that in 2003?
Your answer should be very brief. 1.2. What is the ratio of the Expenditure(as % of GDP) in Hungary in 2000 to that in 2003?
Your answer should be compact. 0.84. What is the ratio of the Expenditure(as % of GDP) in Solomon Islands in 2000 to that in 2003?
Your answer should be compact. 0.76. What is the ratio of the Expenditure(as % of GDP) of Yemen, Rep. in 2000 to that in 2003?
Your response must be concise. 0.83. What is the ratio of the Expenditure(as % of GDP) of Croatia in 2000 to that in 2004?
Provide a succinct answer. 1.17. What is the ratio of the Expenditure(as % of GDP) of Hungary in 2000 to that in 2004?
Offer a very short reply. 0.87. What is the ratio of the Expenditure(as % of GDP) in Solomon Islands in 2000 to that in 2004?
Ensure brevity in your answer.  0.81. What is the ratio of the Expenditure(as % of GDP) of Yemen, Rep. in 2000 to that in 2004?
Provide a short and direct response. 0.84. What is the ratio of the Expenditure(as % of GDP) in Croatia in 2000 to that in 2005?
Offer a terse response. 1.11. What is the ratio of the Expenditure(as % of GDP) in Hungary in 2000 to that in 2005?
Ensure brevity in your answer.  0.85. What is the ratio of the Expenditure(as % of GDP) in Solomon Islands in 2000 to that in 2005?
Your response must be concise. 0.58. What is the ratio of the Expenditure(as % of GDP) in Yemen, Rep. in 2000 to that in 2005?
Keep it short and to the point. 0.9. What is the ratio of the Expenditure(as % of GDP) in Croatia in 2000 to that in 2006?
Keep it short and to the point. 1.1. What is the ratio of the Expenditure(as % of GDP) in Hungary in 2000 to that in 2006?
Give a very brief answer. 0.87. What is the ratio of the Expenditure(as % of GDP) of Solomon Islands in 2000 to that in 2006?
Provide a succinct answer. 0.68. What is the ratio of the Expenditure(as % of GDP) of Yemen, Rep. in 2000 to that in 2006?
Keep it short and to the point. 0.86. What is the ratio of the Expenditure(as % of GDP) of Croatia in 2001 to that in 2002?
Your answer should be very brief. 1.15. What is the ratio of the Expenditure(as % of GDP) of Hungary in 2001 to that in 2002?
Give a very brief answer. 0.95. What is the ratio of the Expenditure(as % of GDP) of Solomon Islands in 2001 to that in 2002?
Provide a short and direct response. 1.06. What is the ratio of the Expenditure(as % of GDP) in Yemen, Rep. in 2001 to that in 2002?
Make the answer very short. 1.03. What is the ratio of the Expenditure(as % of GDP) in Croatia in 2001 to that in 2003?
Your response must be concise. 1.12. What is the ratio of the Expenditure(as % of GDP) in Hungary in 2001 to that in 2003?
Keep it short and to the point. 0.84. What is the ratio of the Expenditure(as % of GDP) in Solomon Islands in 2001 to that in 2003?
Give a very brief answer. 1.07. What is the ratio of the Expenditure(as % of GDP) in Yemen, Rep. in 2001 to that in 2003?
Ensure brevity in your answer.  0.87. What is the ratio of the Expenditure(as % of GDP) in Croatia in 2001 to that in 2004?
Offer a terse response. 1.09. What is the ratio of the Expenditure(as % of GDP) of Hungary in 2001 to that in 2004?
Keep it short and to the point. 0.88. What is the ratio of the Expenditure(as % of GDP) of Solomon Islands in 2001 to that in 2004?
Make the answer very short. 1.14. What is the ratio of the Expenditure(as % of GDP) in Yemen, Rep. in 2001 to that in 2004?
Your answer should be compact. 0.88. What is the ratio of the Expenditure(as % of GDP) of Croatia in 2001 to that in 2005?
Make the answer very short. 1.04. What is the ratio of the Expenditure(as % of GDP) of Hungary in 2001 to that in 2005?
Your answer should be compact. 0.86. What is the ratio of the Expenditure(as % of GDP) in Solomon Islands in 2001 to that in 2005?
Your answer should be compact. 0.82. What is the ratio of the Expenditure(as % of GDP) in Yemen, Rep. in 2001 to that in 2005?
Your answer should be very brief. 0.95. What is the ratio of the Expenditure(as % of GDP) of Croatia in 2001 to that in 2006?
Ensure brevity in your answer.  1.03. What is the ratio of the Expenditure(as % of GDP) in Hungary in 2001 to that in 2006?
Give a very brief answer. 0.88. What is the ratio of the Expenditure(as % of GDP) of Solomon Islands in 2001 to that in 2006?
Your answer should be very brief. 0.97. What is the ratio of the Expenditure(as % of GDP) of Yemen, Rep. in 2001 to that in 2006?
Provide a succinct answer. 0.9. What is the ratio of the Expenditure(as % of GDP) of Croatia in 2002 to that in 2003?
Provide a short and direct response. 0.97. What is the ratio of the Expenditure(as % of GDP) in Hungary in 2002 to that in 2003?
Make the answer very short. 0.89. What is the ratio of the Expenditure(as % of GDP) of Solomon Islands in 2002 to that in 2003?
Your response must be concise. 1.01. What is the ratio of the Expenditure(as % of GDP) of Yemen, Rep. in 2002 to that in 2003?
Give a very brief answer. 0.84. What is the ratio of the Expenditure(as % of GDP) of Croatia in 2002 to that in 2004?
Offer a very short reply. 0.94. What is the ratio of the Expenditure(as % of GDP) of Hungary in 2002 to that in 2004?
Provide a short and direct response. 0.92. What is the ratio of the Expenditure(as % of GDP) of Solomon Islands in 2002 to that in 2004?
Offer a terse response. 1.08. What is the ratio of the Expenditure(as % of GDP) of Yemen, Rep. in 2002 to that in 2004?
Keep it short and to the point. 0.86. What is the ratio of the Expenditure(as % of GDP) of Croatia in 2002 to that in 2005?
Provide a short and direct response. 0.9. What is the ratio of the Expenditure(as % of GDP) in Hungary in 2002 to that in 2005?
Make the answer very short. 0.9. What is the ratio of the Expenditure(as % of GDP) of Solomon Islands in 2002 to that in 2005?
Give a very brief answer. 0.78. What is the ratio of the Expenditure(as % of GDP) in Yemen, Rep. in 2002 to that in 2005?
Give a very brief answer. 0.92. What is the ratio of the Expenditure(as % of GDP) in Croatia in 2002 to that in 2006?
Provide a short and direct response. 0.89. What is the ratio of the Expenditure(as % of GDP) in Hungary in 2002 to that in 2006?
Your answer should be compact. 0.92. What is the ratio of the Expenditure(as % of GDP) in Solomon Islands in 2002 to that in 2006?
Provide a short and direct response. 0.91. What is the ratio of the Expenditure(as % of GDP) in Yemen, Rep. in 2002 to that in 2006?
Your answer should be compact. 0.88. What is the ratio of the Expenditure(as % of GDP) in Croatia in 2003 to that in 2004?
Keep it short and to the point. 0.97. What is the ratio of the Expenditure(as % of GDP) of Hungary in 2003 to that in 2004?
Make the answer very short. 1.04. What is the ratio of the Expenditure(as % of GDP) of Solomon Islands in 2003 to that in 2004?
Ensure brevity in your answer.  1.06. What is the ratio of the Expenditure(as % of GDP) in Yemen, Rep. in 2003 to that in 2004?
Provide a short and direct response. 1.02. What is the ratio of the Expenditure(as % of GDP) of Croatia in 2003 to that in 2005?
Your answer should be compact. 0.92. What is the ratio of the Expenditure(as % of GDP) in Hungary in 2003 to that in 2005?
Ensure brevity in your answer.  1.01. What is the ratio of the Expenditure(as % of GDP) in Solomon Islands in 2003 to that in 2005?
Keep it short and to the point. 0.77. What is the ratio of the Expenditure(as % of GDP) in Yemen, Rep. in 2003 to that in 2005?
Give a very brief answer. 1.09. What is the ratio of the Expenditure(as % of GDP) in Croatia in 2003 to that in 2006?
Offer a very short reply. 0.92. What is the ratio of the Expenditure(as % of GDP) of Hungary in 2003 to that in 2006?
Give a very brief answer. 1.04. What is the ratio of the Expenditure(as % of GDP) in Solomon Islands in 2003 to that in 2006?
Your response must be concise. 0.9. What is the ratio of the Expenditure(as % of GDP) in Yemen, Rep. in 2003 to that in 2006?
Your answer should be compact. 1.04. What is the ratio of the Expenditure(as % of GDP) in Croatia in 2004 to that in 2005?
Offer a terse response. 0.95. What is the ratio of the Expenditure(as % of GDP) of Hungary in 2004 to that in 2005?
Your response must be concise. 0.97. What is the ratio of the Expenditure(as % of GDP) in Solomon Islands in 2004 to that in 2005?
Your answer should be compact. 0.72. What is the ratio of the Expenditure(as % of GDP) of Yemen, Rep. in 2004 to that in 2005?
Your answer should be very brief. 1.07. What is the ratio of the Expenditure(as % of GDP) of Croatia in 2004 to that in 2006?
Ensure brevity in your answer.  0.94. What is the ratio of the Expenditure(as % of GDP) in Solomon Islands in 2004 to that in 2006?
Offer a terse response. 0.85. What is the ratio of the Expenditure(as % of GDP) of Hungary in 2005 to that in 2006?
Your response must be concise. 1.02. What is the ratio of the Expenditure(as % of GDP) of Solomon Islands in 2005 to that in 2006?
Offer a very short reply. 1.18. What is the ratio of the Expenditure(as % of GDP) of Yemen, Rep. in 2005 to that in 2006?
Offer a terse response. 0.95. What is the difference between the highest and the second highest Expenditure(as % of GDP) of Croatia?
Keep it short and to the point. 0.52. What is the difference between the highest and the second highest Expenditure(as % of GDP) of Hungary?
Make the answer very short. 0.12. What is the difference between the highest and the second highest Expenditure(as % of GDP) of Solomon Islands?
Make the answer very short. 1.17. What is the difference between the highest and the second highest Expenditure(as % of GDP) of Yemen, Rep.?
Keep it short and to the point. 0.11. What is the difference between the highest and the lowest Expenditure(as % of GDP) in Croatia?
Your answer should be compact. 1.48. What is the difference between the highest and the lowest Expenditure(as % of GDP) of Hungary?
Keep it short and to the point. 1.39. What is the difference between the highest and the lowest Expenditure(as % of GDP) in Solomon Islands?
Ensure brevity in your answer.  3.27. What is the difference between the highest and the lowest Expenditure(as % of GDP) of Yemen, Rep.?
Make the answer very short. 0.87. 